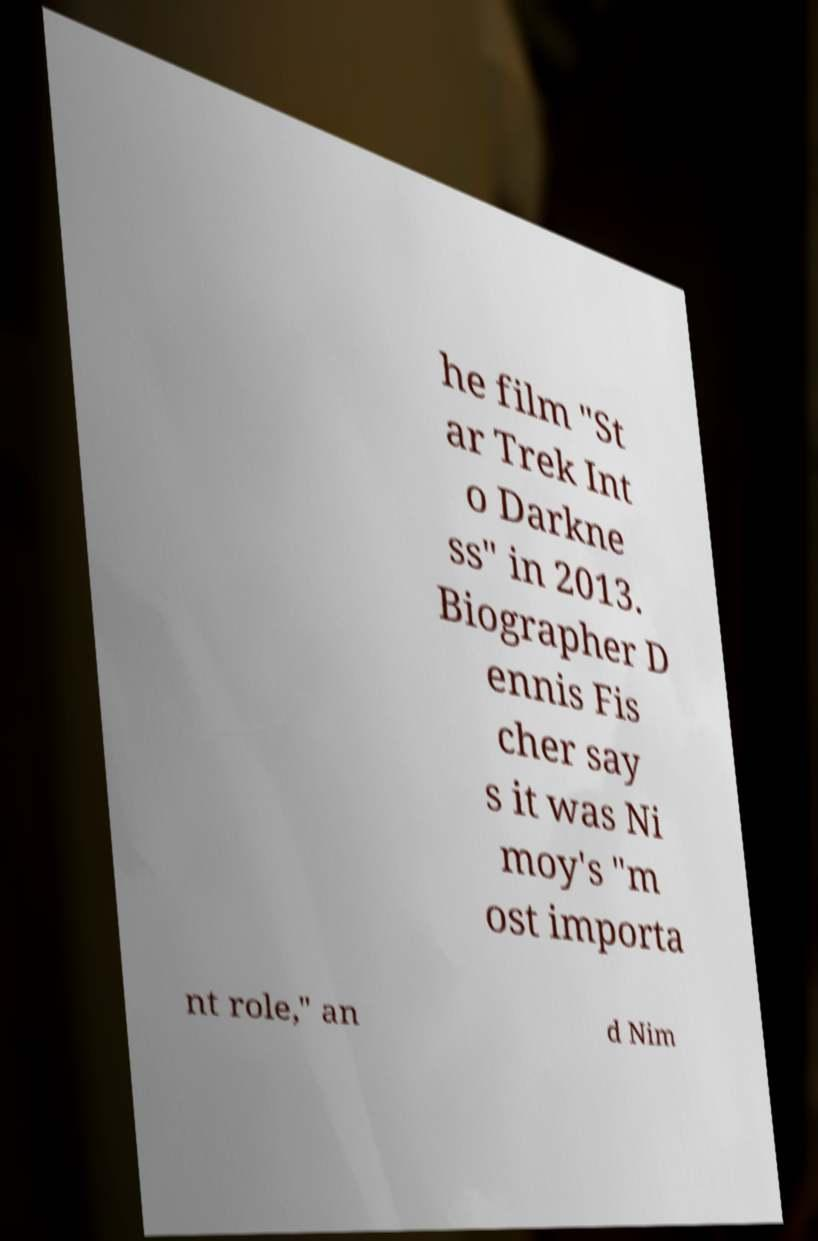Could you extract and type out the text from this image? he film "St ar Trek Int o Darkne ss" in 2013. Biographer D ennis Fis cher say s it was Ni moy's "m ost importa nt role," an d Nim 